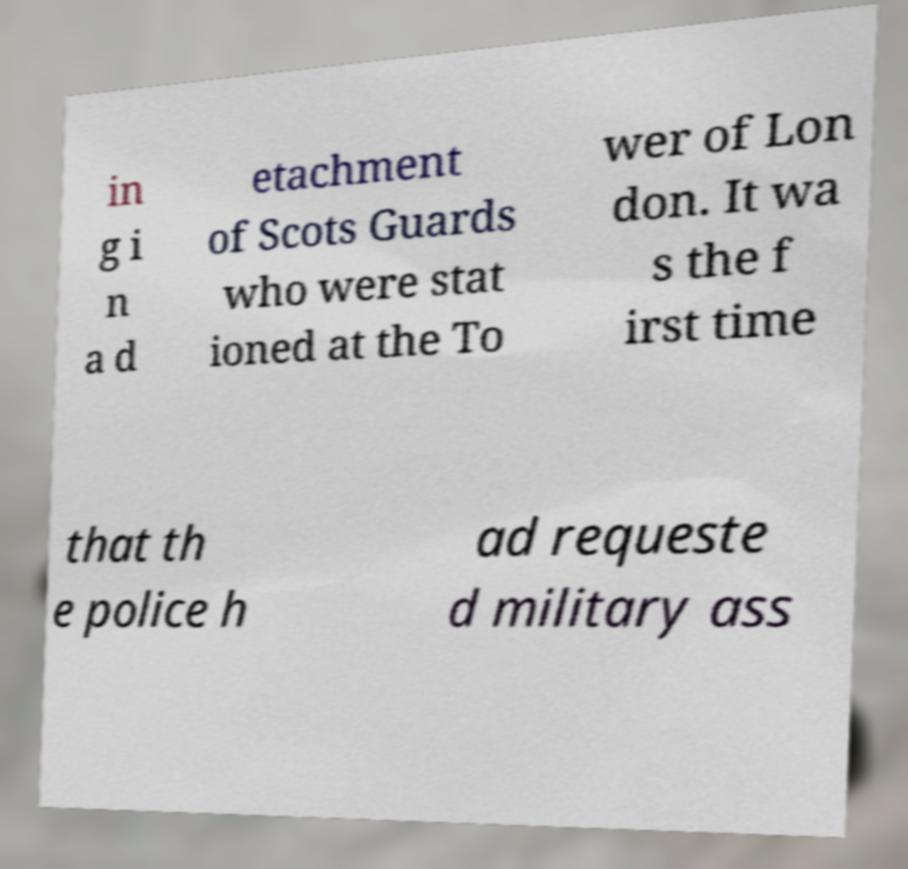Could you assist in decoding the text presented in this image and type it out clearly? in g i n a d etachment of Scots Guards who were stat ioned at the To wer of Lon don. It wa s the f irst time that th e police h ad requeste d military ass 